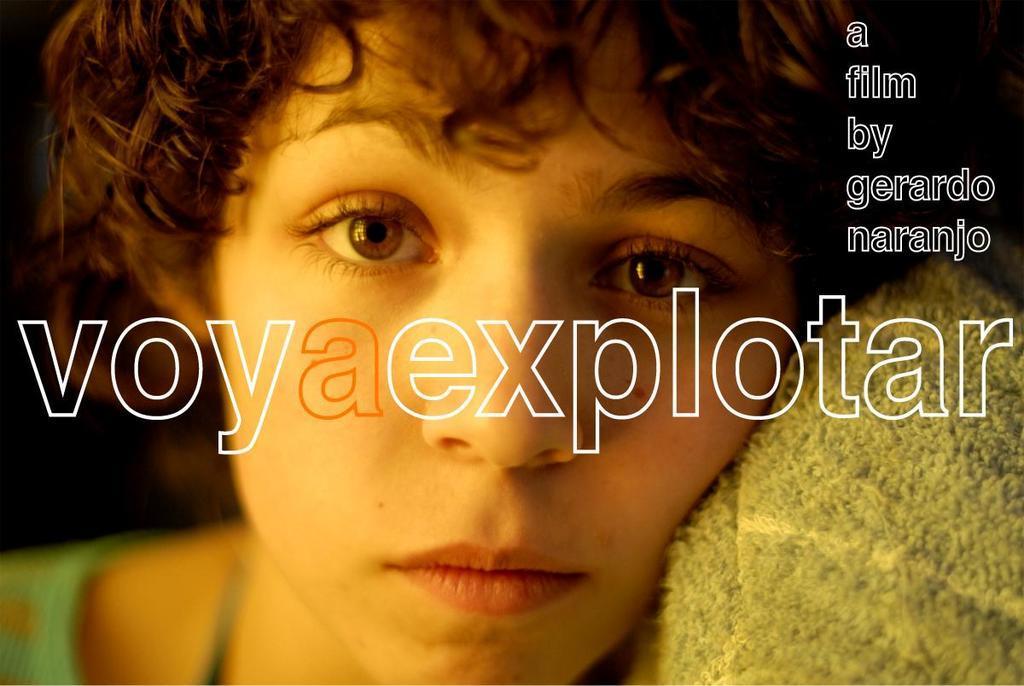Please provide a concise description of this image. This is a cover photo. We see a woman and we see text on the top right and middle of the picture. 